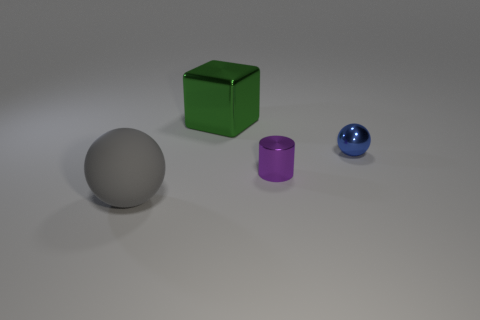What is the size of the ball on the right side of the big gray rubber thing in front of the cylinder?
Offer a very short reply. Small. What number of other things are there of the same size as the block?
Offer a very short reply. 1. What number of cyan metal cubes are there?
Ensure brevity in your answer.  0. Is the green cube the same size as the metallic cylinder?
Your answer should be compact. No. How many other objects are the same shape as the purple shiny thing?
Make the answer very short. 0. What material is the thing right of the tiny object on the left side of the blue sphere?
Provide a short and direct response. Metal. Are there any large green cubes in front of the rubber sphere?
Make the answer very short. No. Does the green shiny block have the same size as the ball to the right of the big gray object?
Provide a succinct answer. No. There is a blue thing that is the same shape as the large gray object; what size is it?
Your answer should be very brief. Small. Is there any other thing that is made of the same material as the large ball?
Keep it short and to the point. No. 